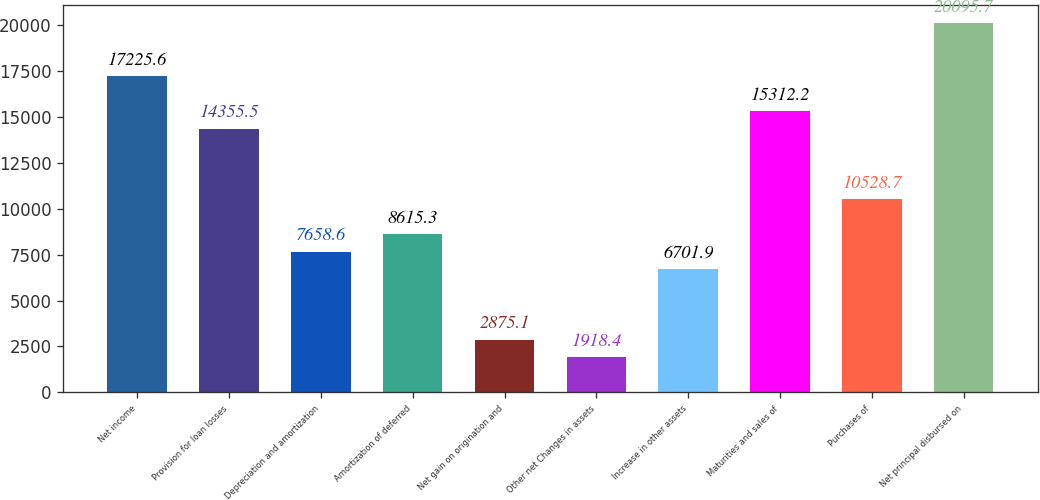<chart> <loc_0><loc_0><loc_500><loc_500><bar_chart><fcel>Net income<fcel>Provision for loan losses<fcel>Depreciation and amortization<fcel>Amortization of deferred<fcel>Net gain on origination and<fcel>Other net Changes in assets<fcel>Increase in other assets<fcel>Maturities and sales of<fcel>Purchases of<fcel>Net principal disbursed on<nl><fcel>17225.6<fcel>14355.5<fcel>7658.6<fcel>8615.3<fcel>2875.1<fcel>1918.4<fcel>6701.9<fcel>15312.2<fcel>10528.7<fcel>20095.7<nl></chart> 